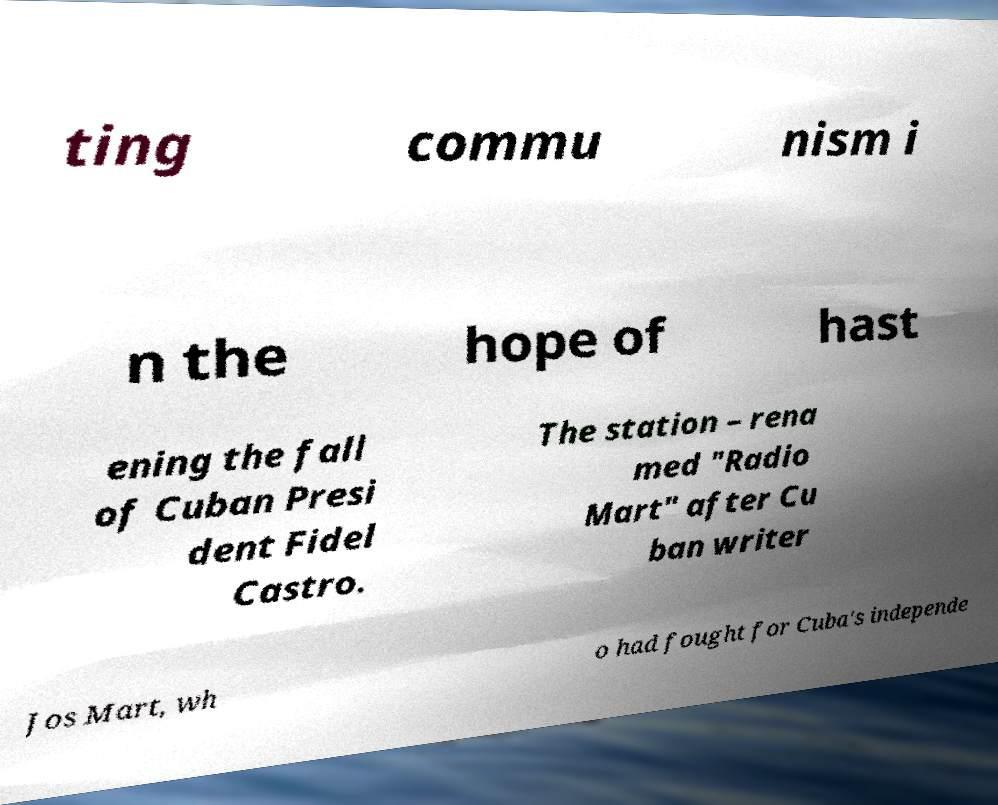Please read and relay the text visible in this image. What does it say? ting commu nism i n the hope of hast ening the fall of Cuban Presi dent Fidel Castro. The station – rena med "Radio Mart" after Cu ban writer Jos Mart, wh o had fought for Cuba's independe 